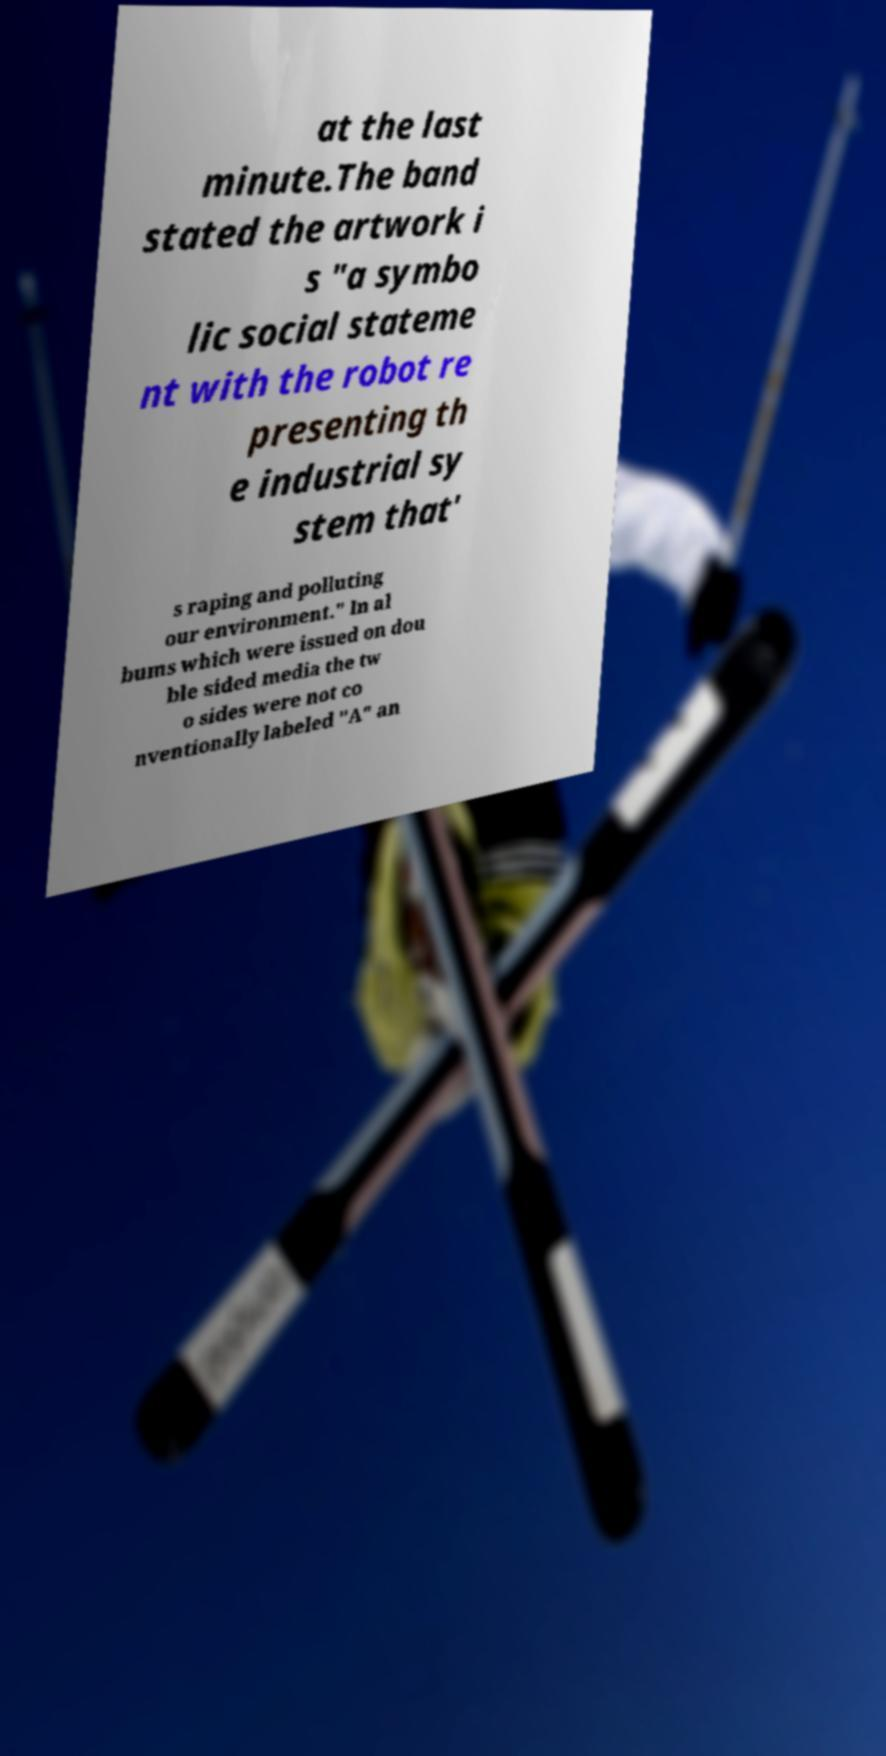Could you assist in decoding the text presented in this image and type it out clearly? at the last minute.The band stated the artwork i s "a symbo lic social stateme nt with the robot re presenting th e industrial sy stem that' s raping and polluting our environment." In al bums which were issued on dou ble sided media the tw o sides were not co nventionally labeled "A" an 